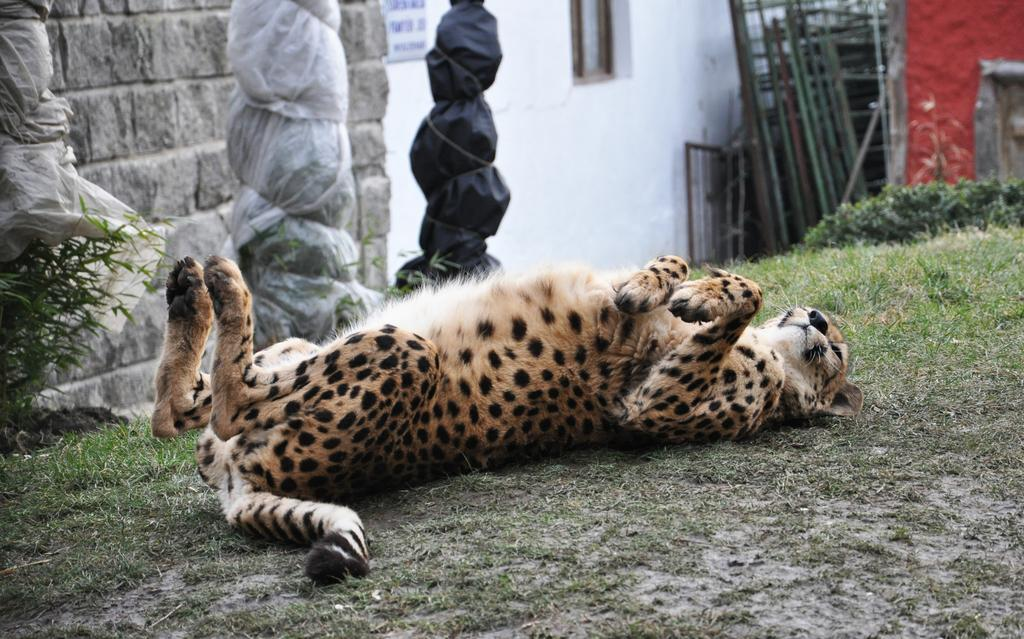What type of animal can be seen in the image? There is a leopard in the image. What is the primary feature of the land in the image? The land is covered with grass. What structures can be seen in the background of the image? There are walls, a window, and a board in the background of the image. What type of vegetation is present in the background of the image? A: There are plants in the background of the image. What objects are covered with plastic in the image? There are plastic covers in the image. What type of corn is being harvested in the scene depicted in the image? There is no corn present in the image, nor is there a scene of harvesting depicted. 